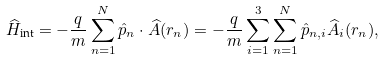<formula> <loc_0><loc_0><loc_500><loc_500>\widehat { H } _ { \text {int} } = - \frac { q } { m } \sum _ { n = 1 } ^ { N } \hat { p } _ { n } \cdot \widehat { A } ( r _ { n } ) = - \frac { q } { m } \sum _ { i = 1 } ^ { 3 } \sum _ { n = 1 } ^ { N } \hat { p } _ { n , i } \widehat { A } _ { i } ( r _ { n } ) ,</formula> 